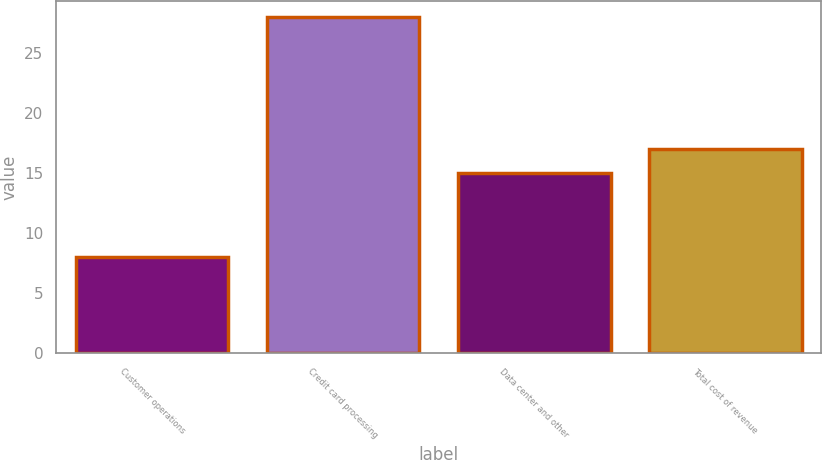Convert chart. <chart><loc_0><loc_0><loc_500><loc_500><bar_chart><fcel>Customer operations<fcel>Credit card processing<fcel>Data center and other<fcel>Total cost of revenue<nl><fcel>8<fcel>28<fcel>15<fcel>17<nl></chart> 